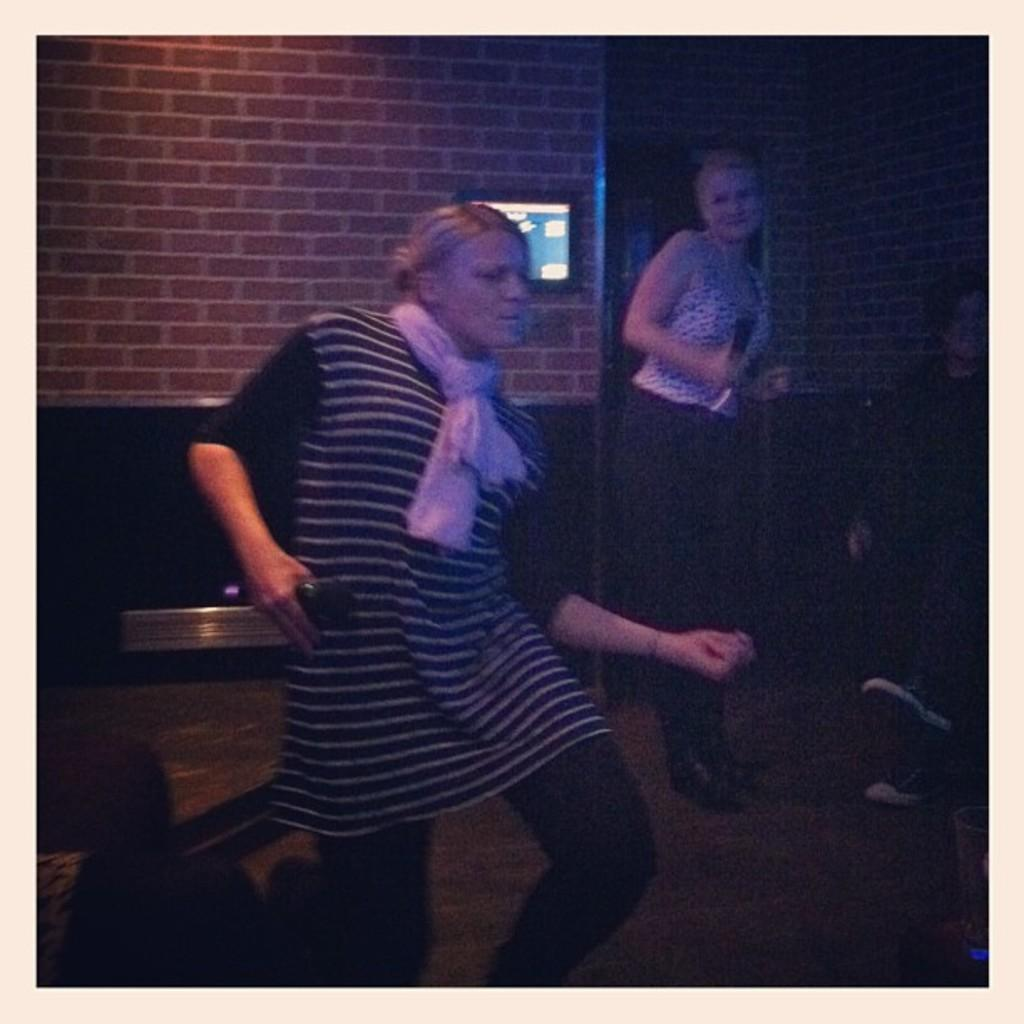How many people are in the image? There are three persons in the image. What are the positions of the persons in the image? Some of the persons are standing. What object can be seen in the image? There is a screen in the image. How would you describe the lighting in the image? The image appears to be slightly dark. How many giants are present in the image? There are no giants present in the image; it features three persons. What type of tree can be seen in the image? There is no tree present in the image. 